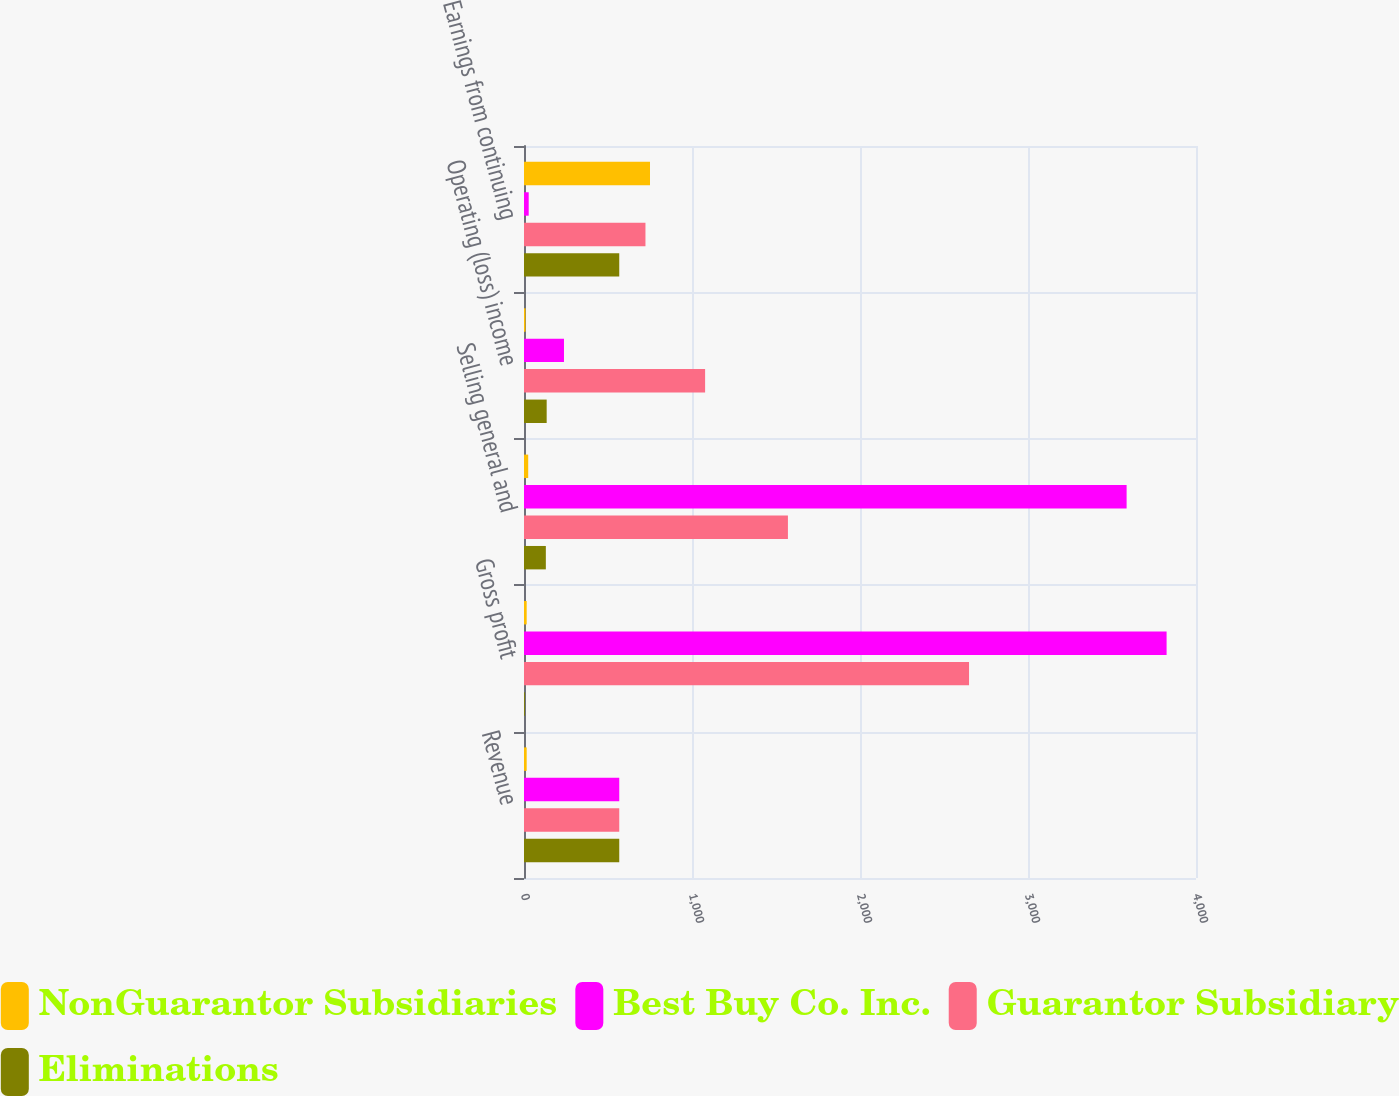Convert chart to OTSL. <chart><loc_0><loc_0><loc_500><loc_500><stacked_bar_chart><ecel><fcel>Revenue<fcel>Gross profit<fcel>Selling general and<fcel>Operating (loss) income<fcel>Earnings from continuing<nl><fcel>NonGuarantor Subsidiaries<fcel>16<fcel>16<fcel>25<fcel>9<fcel>750<nl><fcel>Best Buy Co. Inc.<fcel>567<fcel>3825<fcel>3587<fcel>238<fcel>28<nl><fcel>Guarantor Subsidiary<fcel>567<fcel>2649<fcel>1571<fcel>1078<fcel>723<nl><fcel>Eliminations<fcel>567<fcel>5<fcel>130<fcel>135<fcel>567<nl></chart> 